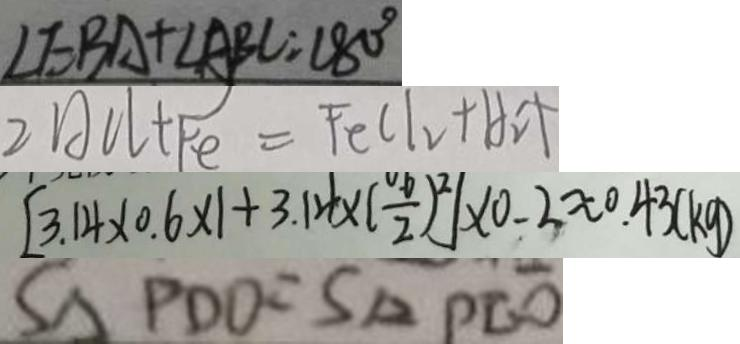<formula> <loc_0><loc_0><loc_500><loc_500>\angle E B A + \angle A B C = 1 8 0 ^ { \circ } 
 2 A C l + F e = F e C l _ { 2 } + H _ { 2 } \uparrow 
 [ 3 . 1 4 \times 0 . 6 \times 1 + 3 . 1 4 \times ( \frac { 0 . 6 } { 2 } ) ^ { 2 } ] \times 0 . 2 \approx 0 . 4 3 ( k g ) 
 S _ { \Delta P D O } = S _ { \Delta } P E O</formula> 